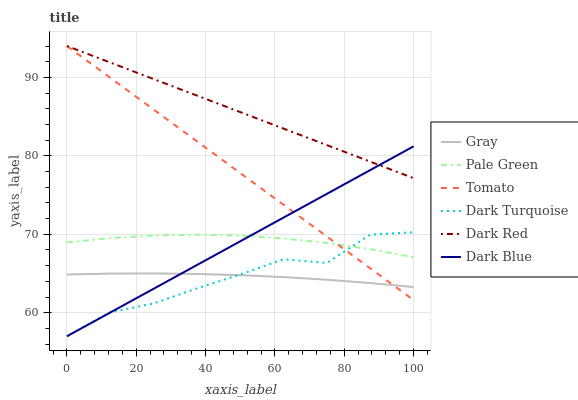Does Gray have the minimum area under the curve?
Answer yes or no. No. Does Gray have the maximum area under the curve?
Answer yes or no. No. Is Gray the smoothest?
Answer yes or no. No. Is Gray the roughest?
Answer yes or no. No. Does Gray have the lowest value?
Answer yes or no. No. Does Gray have the highest value?
Answer yes or no. No. Is Dark Turquoise less than Dark Red?
Answer yes or no. Yes. Is Dark Red greater than Dark Turquoise?
Answer yes or no. Yes. Does Dark Turquoise intersect Dark Red?
Answer yes or no. No. 